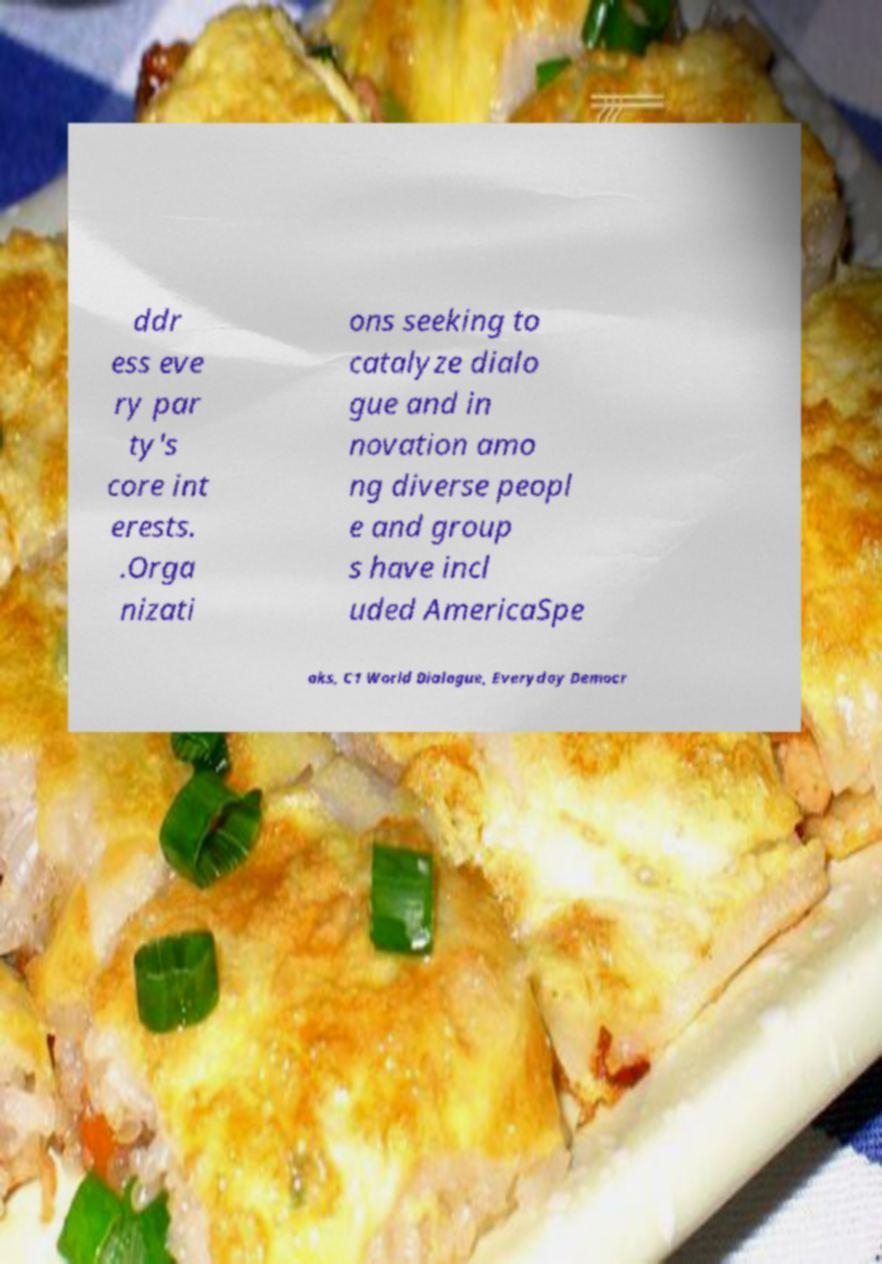Can you accurately transcribe the text from the provided image for me? ddr ess eve ry par ty's core int erests. .Orga nizati ons seeking to catalyze dialo gue and in novation amo ng diverse peopl e and group s have incl uded AmericaSpe aks, C1 World Dialogue, Everyday Democr 